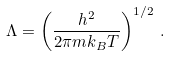Convert formula to latex. <formula><loc_0><loc_0><loc_500><loc_500>\Lambda = \left ( \frac { h ^ { 2 } } { 2 \pi m k _ { B } T } \right ) ^ { 1 / 2 } \, .</formula> 